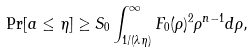Convert formula to latex. <formula><loc_0><loc_0><loc_500><loc_500>\Pr [ a \leq \eta ] \geq S _ { 0 } \int _ { 1 / ( \lambda \eta ) } ^ { \infty } F _ { 0 } ( \rho ) ^ { 2 } \rho ^ { n - 1 } d \rho ,</formula> 